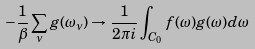<formula> <loc_0><loc_0><loc_500><loc_500>- \frac { 1 } { \beta } \sum _ { \nu } g ( \omega _ { \nu } ) \rightarrow \frac { 1 } { 2 \pi i } \int _ { C _ { 0 } } f ( \omega ) g ( \omega ) d \omega</formula> 